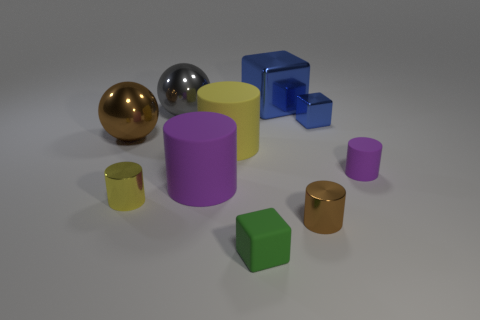There is a small metallic cylinder behind the tiny brown object; are there any small brown cylinders in front of it?
Give a very brief answer. Yes. Do the big cylinder that is in front of the tiny purple cylinder and the rubber cylinder that is right of the big blue cube have the same color?
Offer a very short reply. Yes. How many metal things are the same size as the gray ball?
Offer a terse response. 2. There is a brown metal thing that is on the right side of the yellow metal cylinder; is it the same size as the large brown metallic object?
Offer a terse response. No. The tiny blue object has what shape?
Keep it short and to the point. Cube. There is a object that is the same color as the big block; what size is it?
Provide a short and direct response. Small. Is the blue cube behind the tiny blue shiny block made of the same material as the small blue thing?
Provide a short and direct response. Yes. Is there another cylinder of the same color as the tiny matte cylinder?
Give a very brief answer. Yes. There is a blue object that is left of the small blue cube; is it the same shape as the tiny metal thing behind the big yellow thing?
Your response must be concise. Yes. Is there a tiny yellow ball that has the same material as the big yellow cylinder?
Keep it short and to the point. No. 